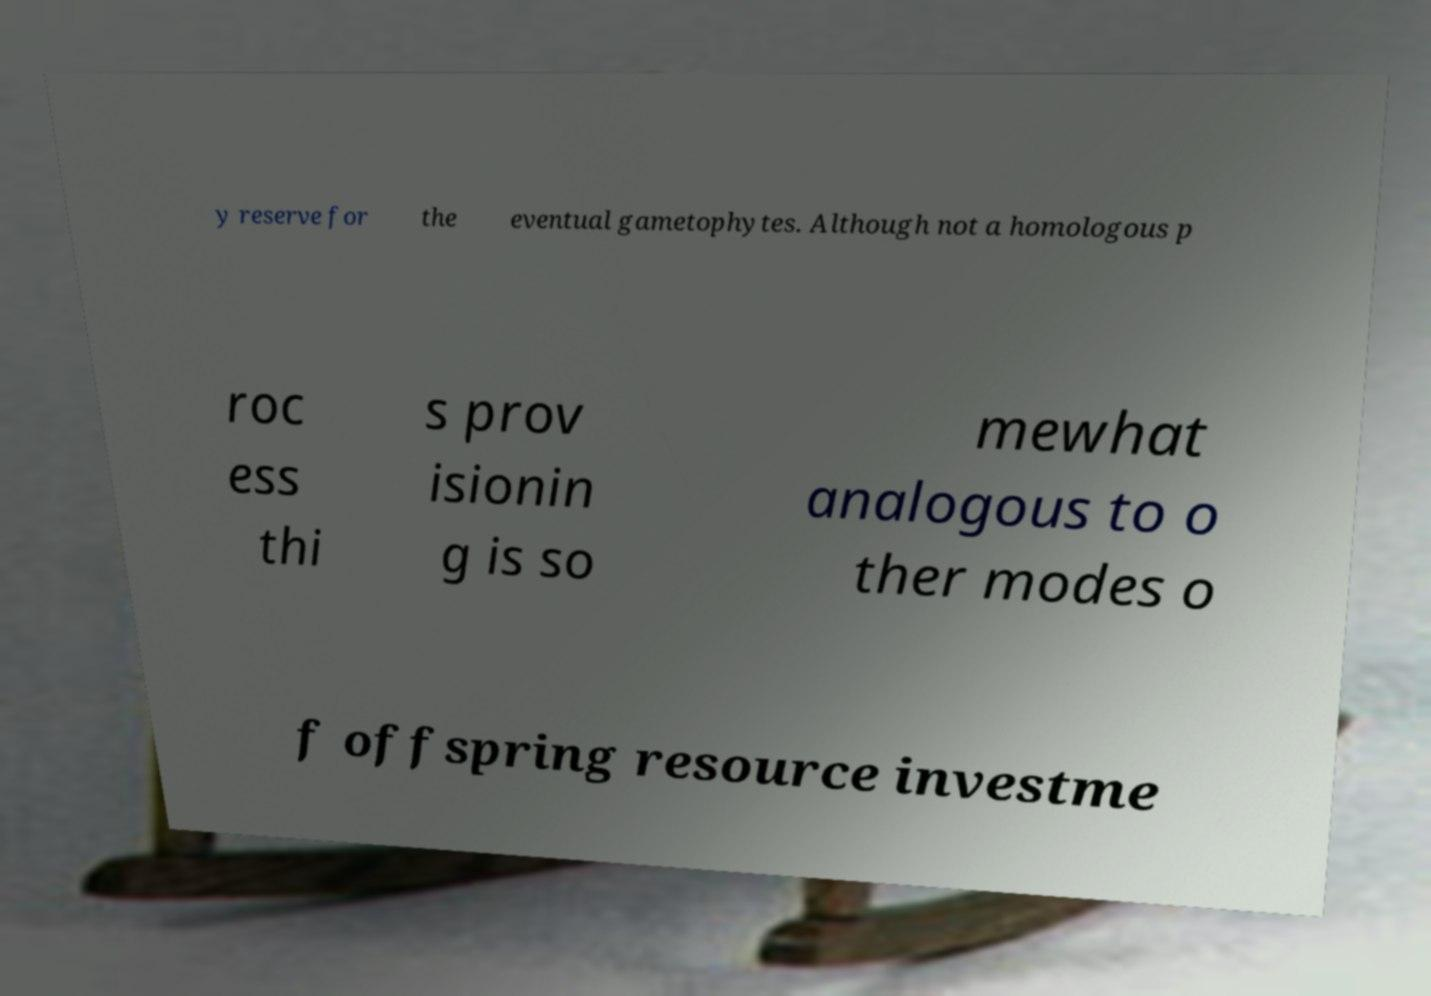Please identify and transcribe the text found in this image. y reserve for the eventual gametophytes. Although not a homologous p roc ess thi s prov isionin g is so mewhat analogous to o ther modes o f offspring resource investme 